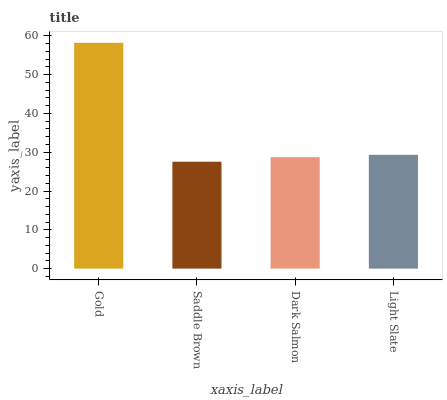Is Saddle Brown the minimum?
Answer yes or no. Yes. Is Gold the maximum?
Answer yes or no. Yes. Is Dark Salmon the minimum?
Answer yes or no. No. Is Dark Salmon the maximum?
Answer yes or no. No. Is Dark Salmon greater than Saddle Brown?
Answer yes or no. Yes. Is Saddle Brown less than Dark Salmon?
Answer yes or no. Yes. Is Saddle Brown greater than Dark Salmon?
Answer yes or no. No. Is Dark Salmon less than Saddle Brown?
Answer yes or no. No. Is Light Slate the high median?
Answer yes or no. Yes. Is Dark Salmon the low median?
Answer yes or no. Yes. Is Dark Salmon the high median?
Answer yes or no. No. Is Light Slate the low median?
Answer yes or no. No. 